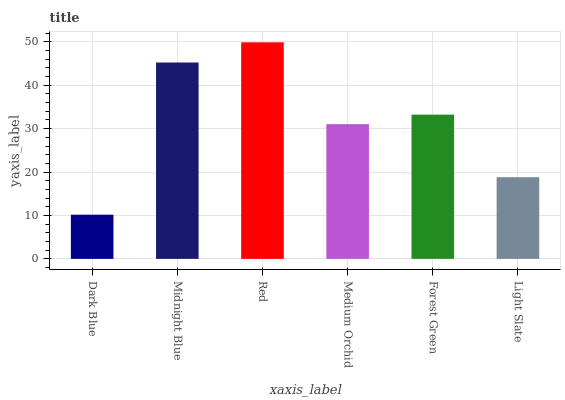Is Dark Blue the minimum?
Answer yes or no. Yes. Is Red the maximum?
Answer yes or no. Yes. Is Midnight Blue the minimum?
Answer yes or no. No. Is Midnight Blue the maximum?
Answer yes or no. No. Is Midnight Blue greater than Dark Blue?
Answer yes or no. Yes. Is Dark Blue less than Midnight Blue?
Answer yes or no. Yes. Is Dark Blue greater than Midnight Blue?
Answer yes or no. No. Is Midnight Blue less than Dark Blue?
Answer yes or no. No. Is Forest Green the high median?
Answer yes or no. Yes. Is Medium Orchid the low median?
Answer yes or no. Yes. Is Midnight Blue the high median?
Answer yes or no. No. Is Forest Green the low median?
Answer yes or no. No. 